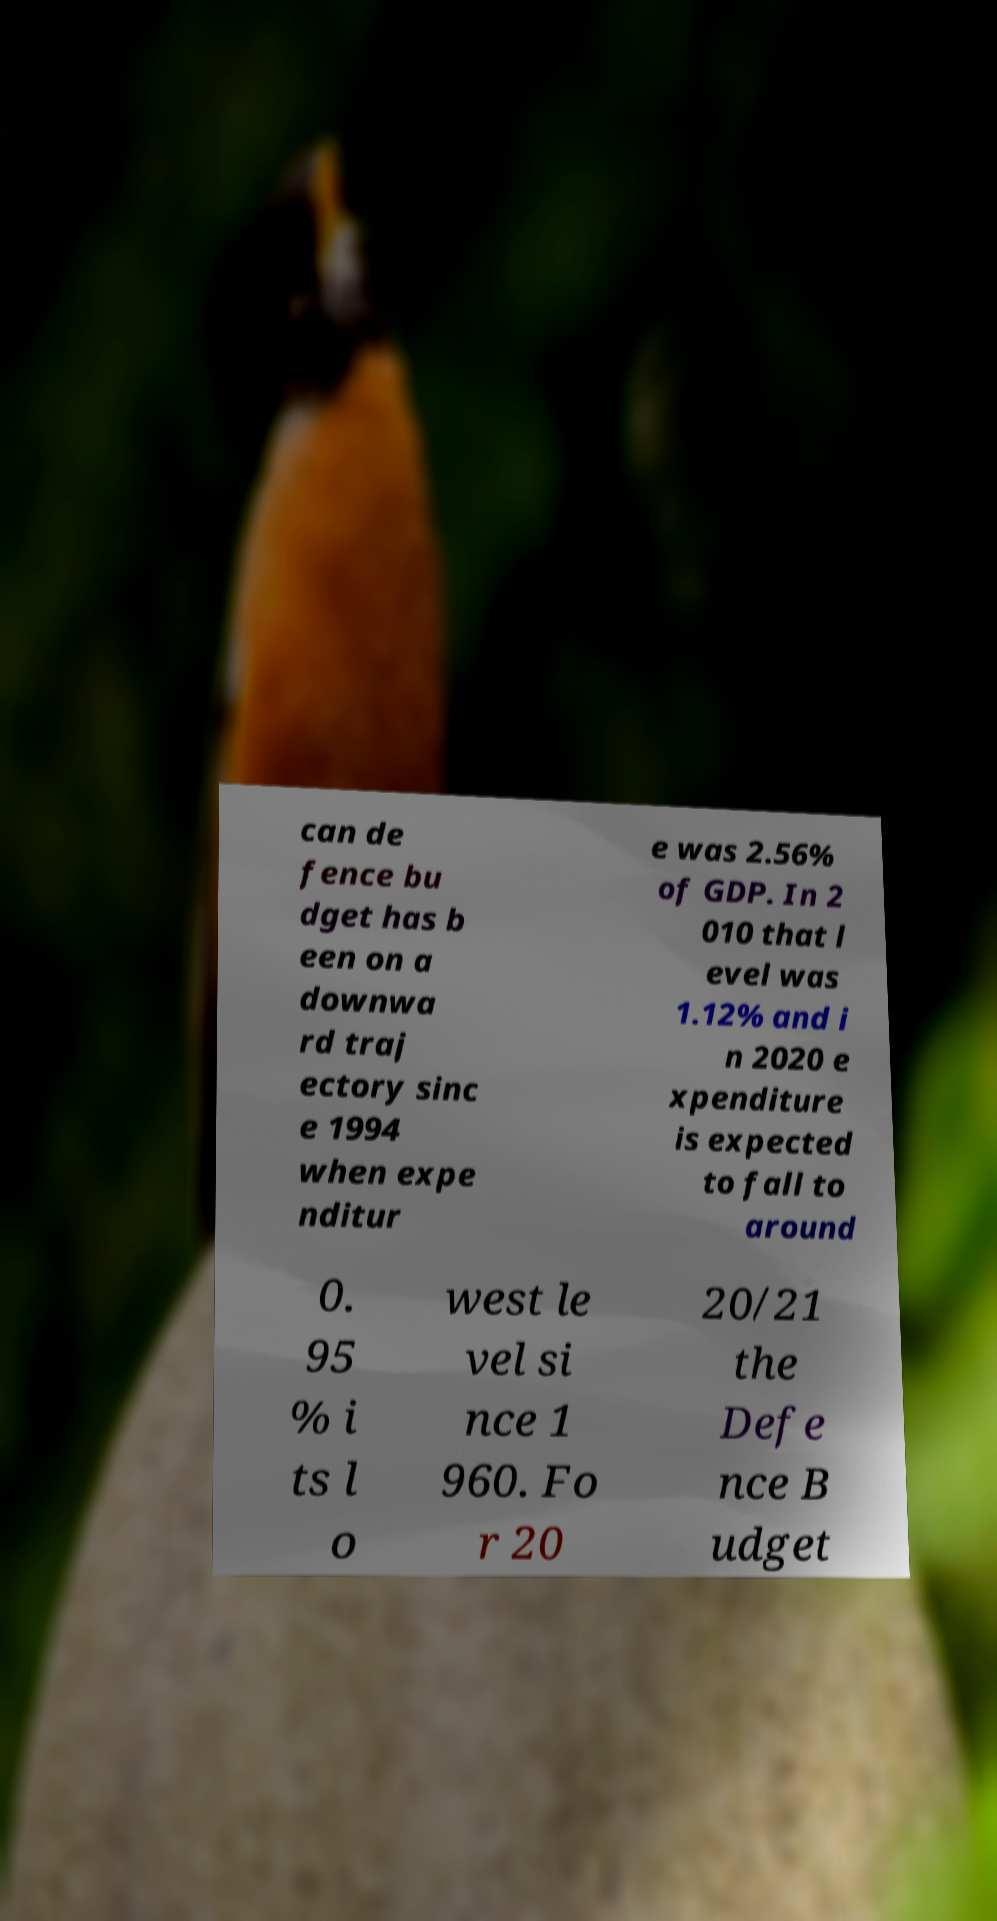Can you read and provide the text displayed in the image?This photo seems to have some interesting text. Can you extract and type it out for me? can de fence bu dget has b een on a downwa rd traj ectory sinc e 1994 when expe nditur e was 2.56% of GDP. In 2 010 that l evel was 1.12% and i n 2020 e xpenditure is expected to fall to around 0. 95 % i ts l o west le vel si nce 1 960. Fo r 20 20/21 the Defe nce B udget 